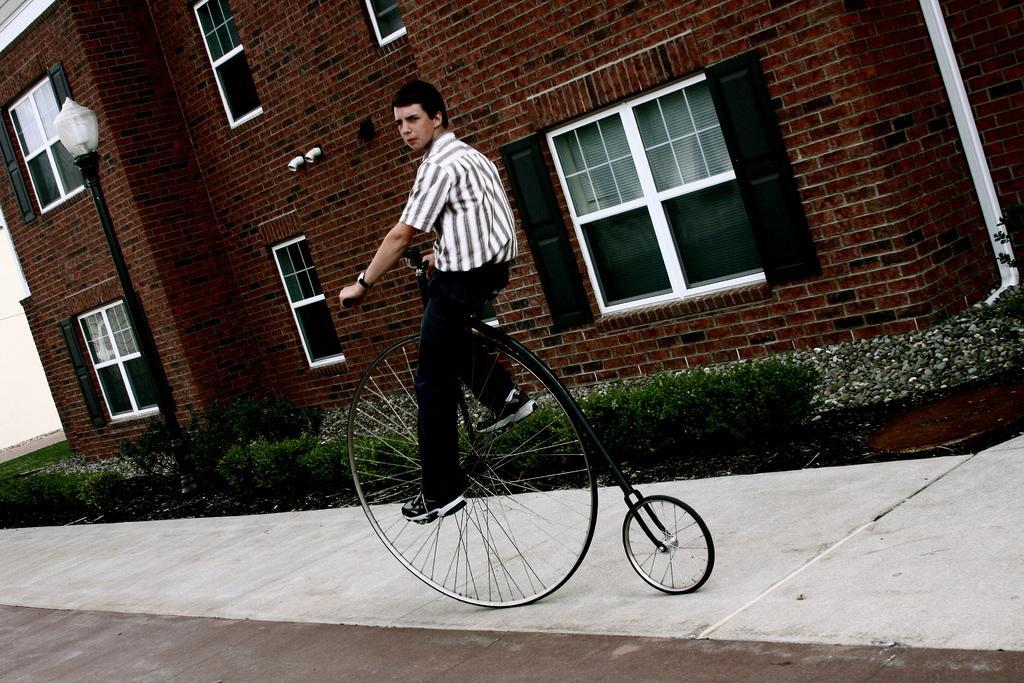Describe this image in one or two sentences. A wearing a black and white shirt is wearing a watch is riding a unicycle on the sidewalk. Behind that there are bushes. Some pebbles are also there near the house. For the house it is red brick and windows are there. And there is light stand near the bushes. 